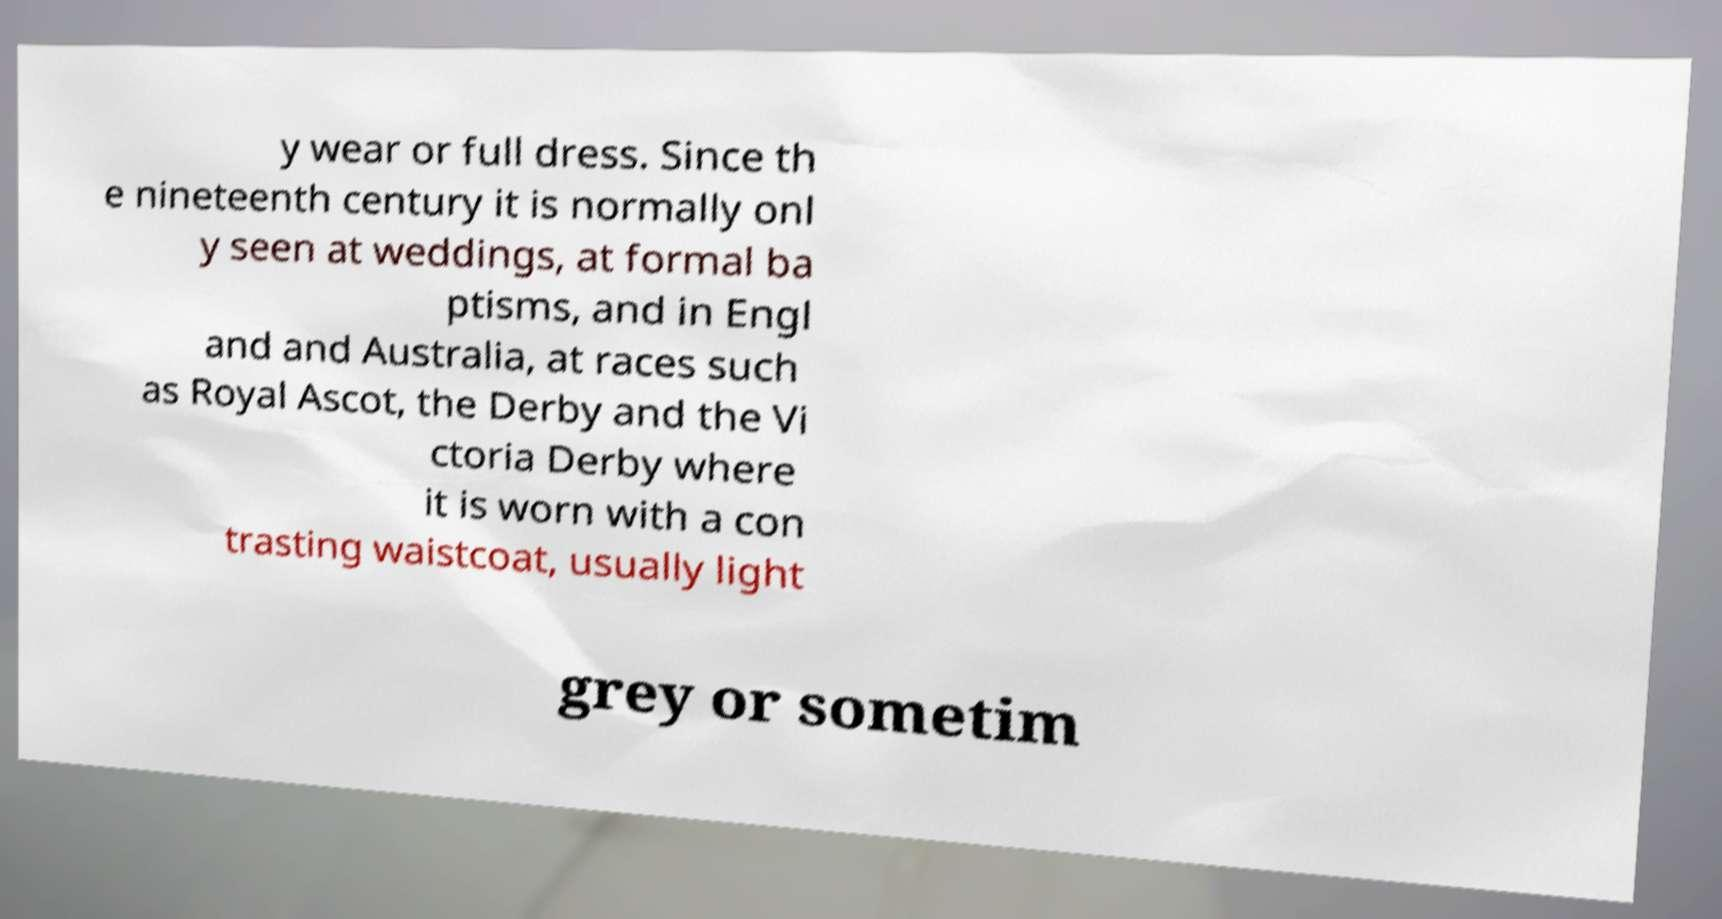What messages or text are displayed in this image? I need them in a readable, typed format. y wear or full dress. Since th e nineteenth century it is normally onl y seen at weddings, at formal ba ptisms, and in Engl and and Australia, at races such as Royal Ascot, the Derby and the Vi ctoria Derby where it is worn with a con trasting waistcoat, usually light grey or sometim 